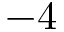Convert formula to latex. <formula><loc_0><loc_0><loc_500><loc_500>- 4</formula> 